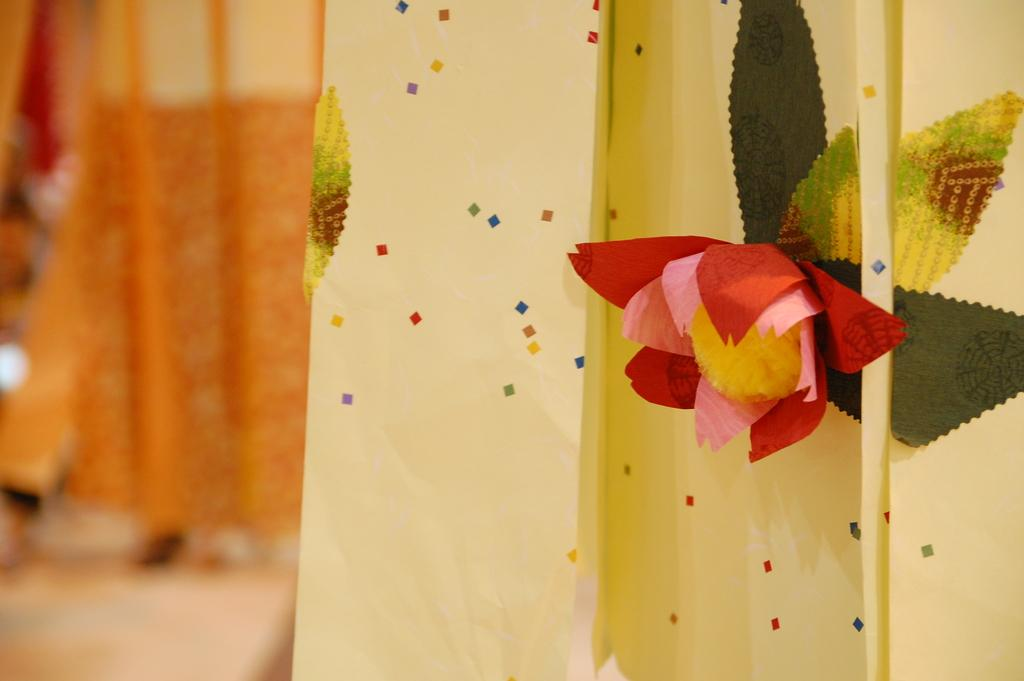What is the main subject of the image? There is a flower in the image. Can you describe the colors of the flower? The flower has red, pink, and yellow colors. What else can be seen in the image besides the flower? There are green leaves in the image. What color is the background wall in the image? The background wall is in light yellow color. What type of curtain is present in the image? There is an orange curtain in the image. What type of prose is being recited by the beast in the image? There is no beast or prose present in the image; it features a flower, green leaves, a light yellow background wall, and an orange curtain. 